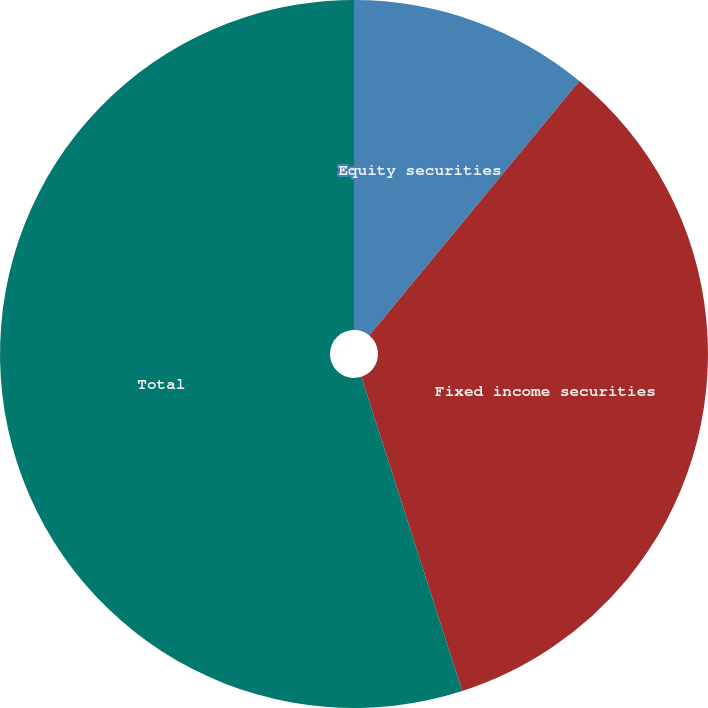Convert chart to OTSL. <chart><loc_0><loc_0><loc_500><loc_500><pie_chart><fcel>Equity securities<fcel>Fixed income securities<fcel>Total<nl><fcel>10.99%<fcel>34.07%<fcel>54.95%<nl></chart> 